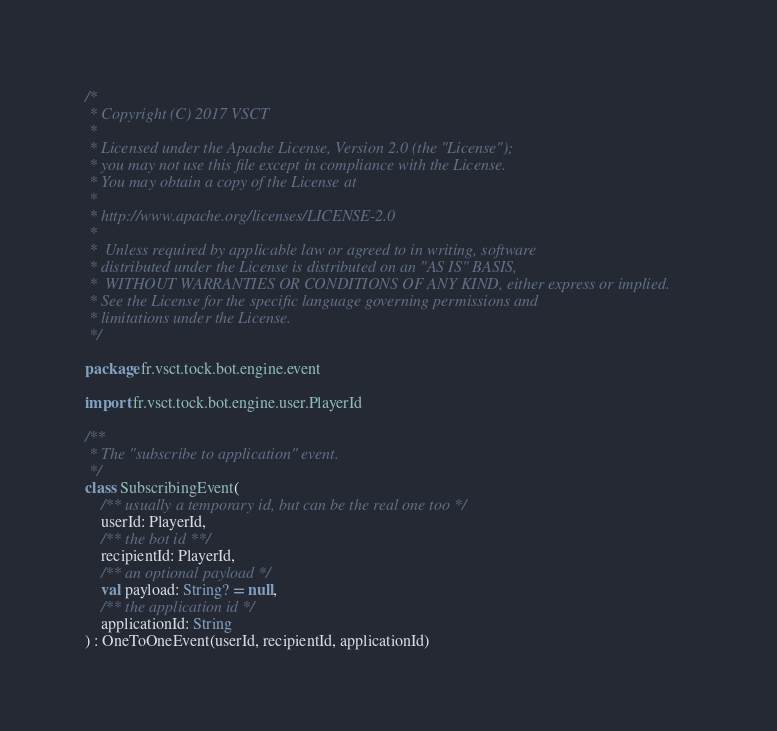<code> <loc_0><loc_0><loc_500><loc_500><_Kotlin_>/*
 * Copyright (C) 2017 VSCT
 *
 * Licensed under the Apache License, Version 2.0 (the "License");
 * you may not use this file except in compliance with the License.
 * You may obtain a copy of the License at
 *
 * http://www.apache.org/licenses/LICENSE-2.0
 *
 *  Unless required by applicable law or agreed to in writing, software
 * distributed under the License is distributed on an "AS IS" BASIS,
 *  WITHOUT WARRANTIES OR CONDITIONS OF ANY KIND, either express or implied.
 * See the License for the specific language governing permissions and
 * limitations under the License.
 */

package fr.vsct.tock.bot.engine.event

import fr.vsct.tock.bot.engine.user.PlayerId

/**
 * The "subscribe to application" event.
 */
class SubscribingEvent(
    /** usually a temporary id, but can be the real one too */
    userId: PlayerId,
    /** the bot id **/
    recipientId: PlayerId,
    /** an optional payload */
    val payload: String? = null,
    /** the application id */
    applicationId: String
) : OneToOneEvent(userId, recipientId, applicationId)</code> 